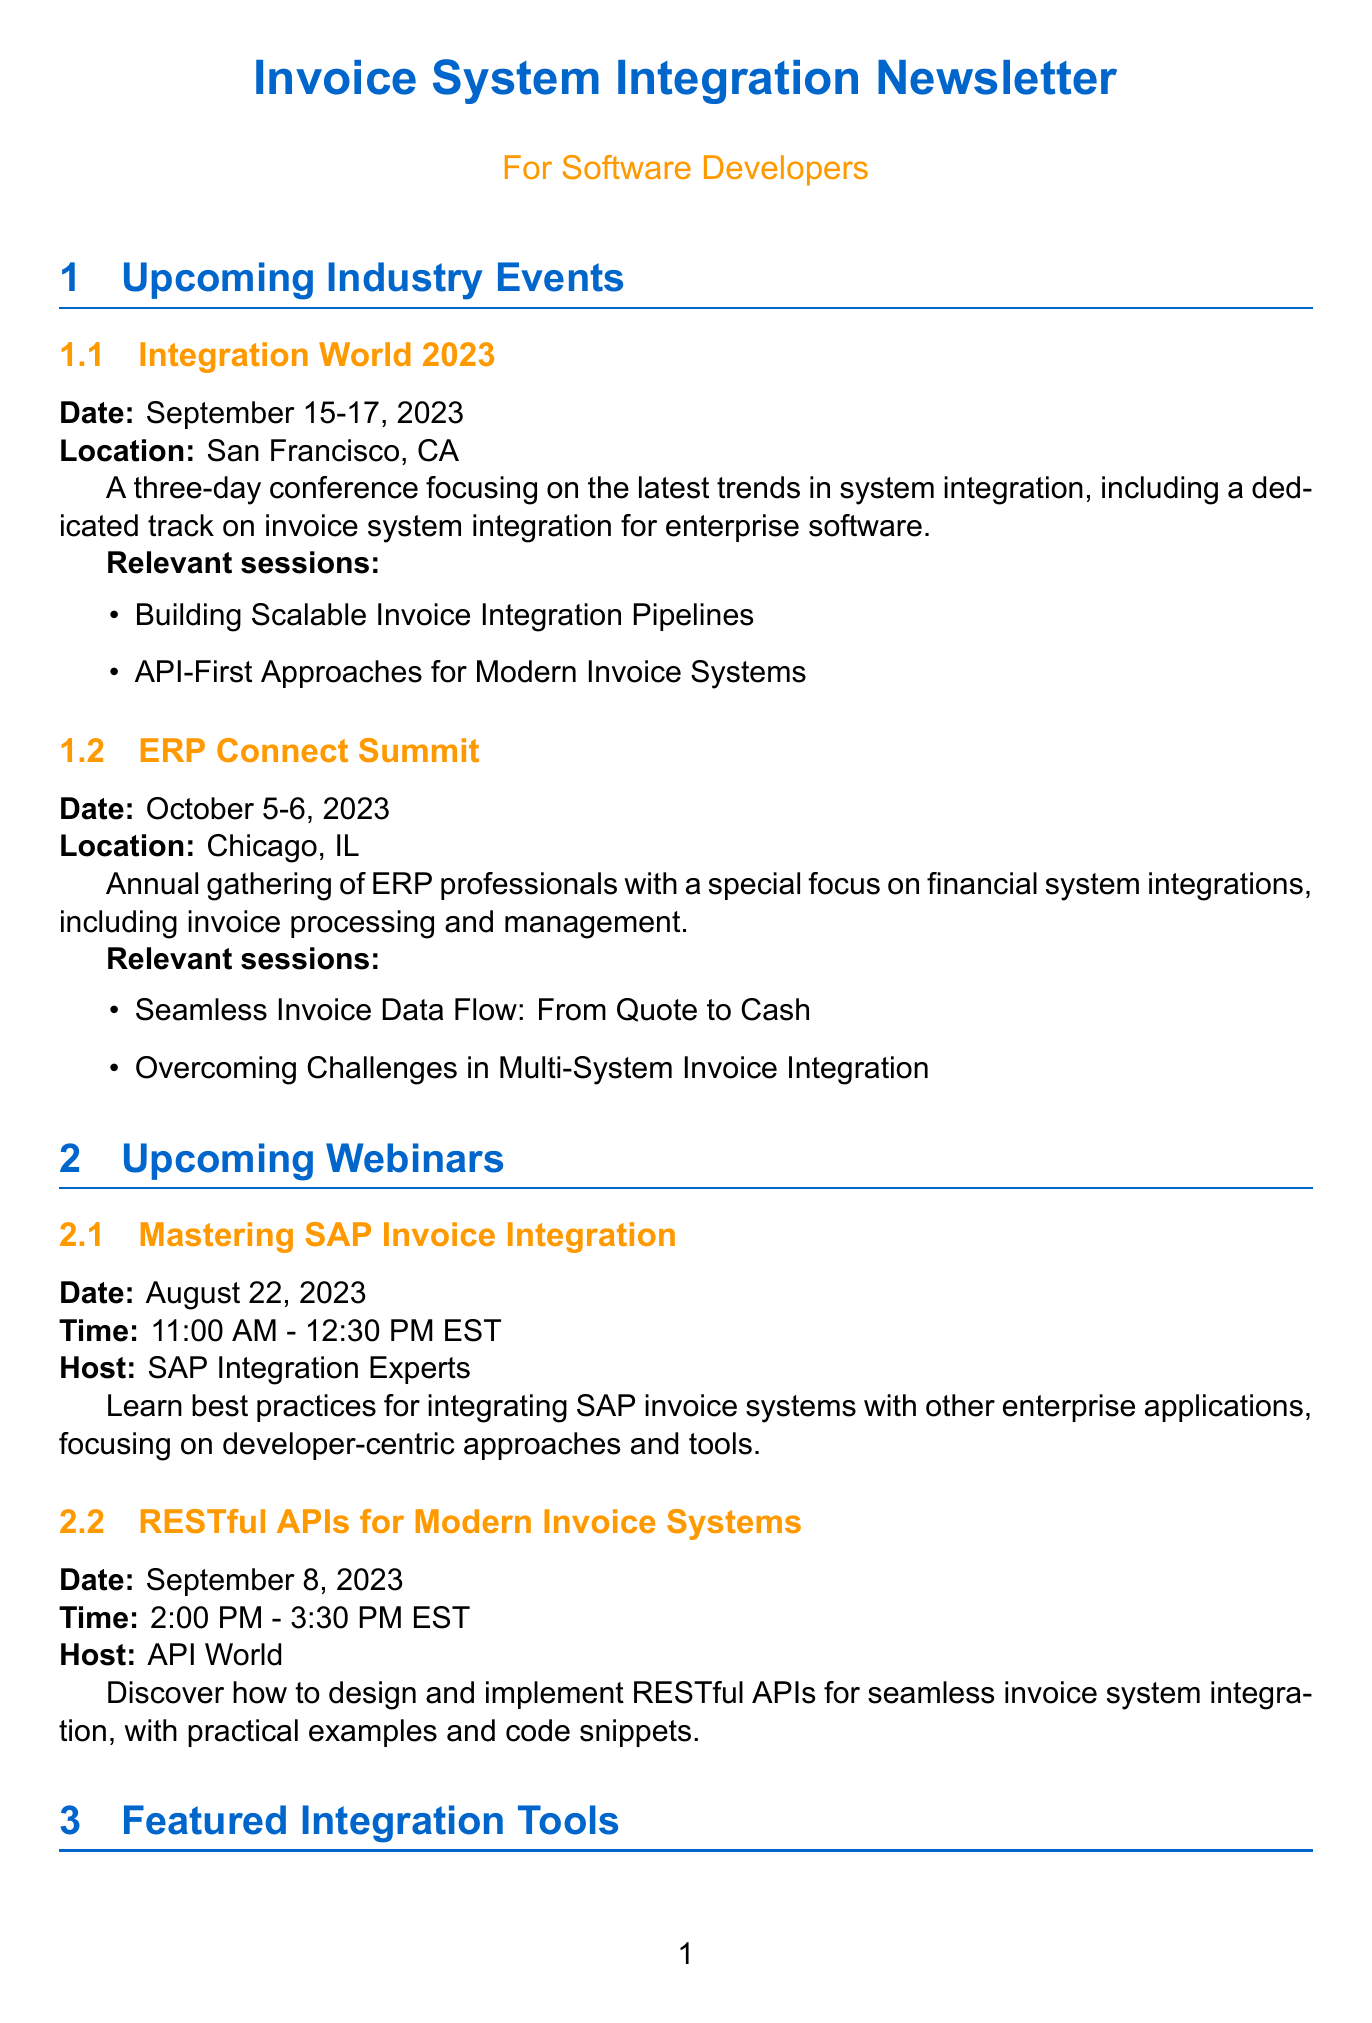What is the date of Integration World 2023? The date for Integration World 2023 is specified in the event details under the title, which is September 15-17, 2023.
Answer: September 15-17, 2023 Where is the ERP Connect Summit being held? The location of the ERP Connect Summit is explicitly mentioned in the event section, which is Chicago, IL.
Answer: Chicago, IL Who is hosting the webinar on RESTful APIs for Modern Invoice Systems? The host of the webinar is listed in the webinar details for RESTful APIs, which is API World.
Answer: API World What session focuses on overcoming challenges in invoice integration? The session addressing this topic is named "Overcoming Challenges in Multi-System Invoice Integration," found in the ERP Connect Summit section.
Answer: Overcoming Challenges in Multi-System Invoice Integration Which integration tool offers a low-code development environment? The document states that Dell Boomi AtomSphere features a low-code development environment in the tools section.
Answer: Dell Boomi AtomSphere What key point discusses intelligent data capture? The key point related to intelligent data capture is found under "The Rise of AI in Invoice Processing," specifically mentioning machine learning algorithms.
Answer: Machine learning algorithms for intelligent data capture How many days does Integration World 2023 last? The duration of Integration World 2023 can be calculated from the specified dates, which span three days.
Answer: Three days What is the main focus of the upcoming webinars? The webinars primarily focus on invoice system integration, which is highlighted in the titles and descriptions throughout the webinar section.
Answer: Invoice system integration 